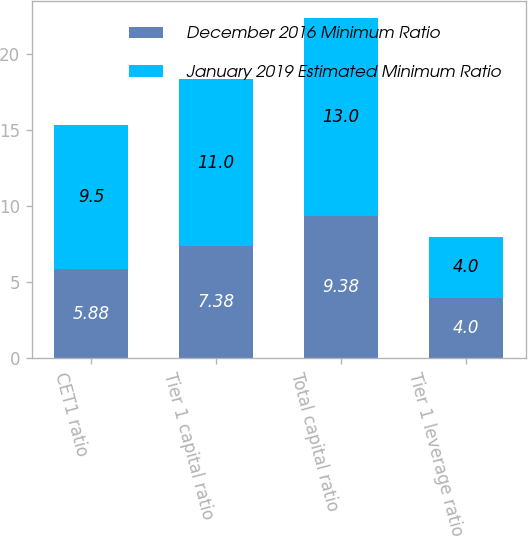Convert chart. <chart><loc_0><loc_0><loc_500><loc_500><stacked_bar_chart><ecel><fcel>CET1 ratio<fcel>Tier 1 capital ratio<fcel>Total capital ratio<fcel>Tier 1 leverage ratio<nl><fcel>December 2016 Minimum Ratio<fcel>5.88<fcel>7.38<fcel>9.38<fcel>4<nl><fcel>January 2019 Estimated Minimum Ratio<fcel>9.5<fcel>11<fcel>13<fcel>4<nl></chart> 